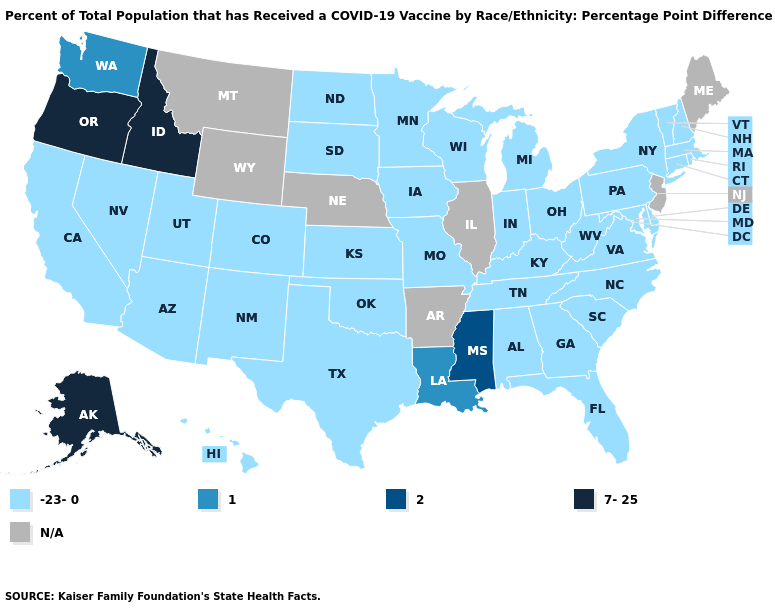Name the states that have a value in the range 2?
Keep it brief. Mississippi. What is the value of Wyoming?
Answer briefly. N/A. Name the states that have a value in the range 2?
Write a very short answer. Mississippi. Name the states that have a value in the range N/A?
Answer briefly. Arkansas, Illinois, Maine, Montana, Nebraska, New Jersey, Wyoming. Name the states that have a value in the range 7-25?
Give a very brief answer. Alaska, Idaho, Oregon. Name the states that have a value in the range 1?
Short answer required. Louisiana, Washington. Is the legend a continuous bar?
Concise answer only. No. Name the states that have a value in the range 2?
Short answer required. Mississippi. What is the highest value in states that border California?
Keep it brief. 7-25. What is the value of Indiana?
Keep it brief. -23-0. Which states have the lowest value in the MidWest?
Short answer required. Indiana, Iowa, Kansas, Michigan, Minnesota, Missouri, North Dakota, Ohio, South Dakota, Wisconsin. 